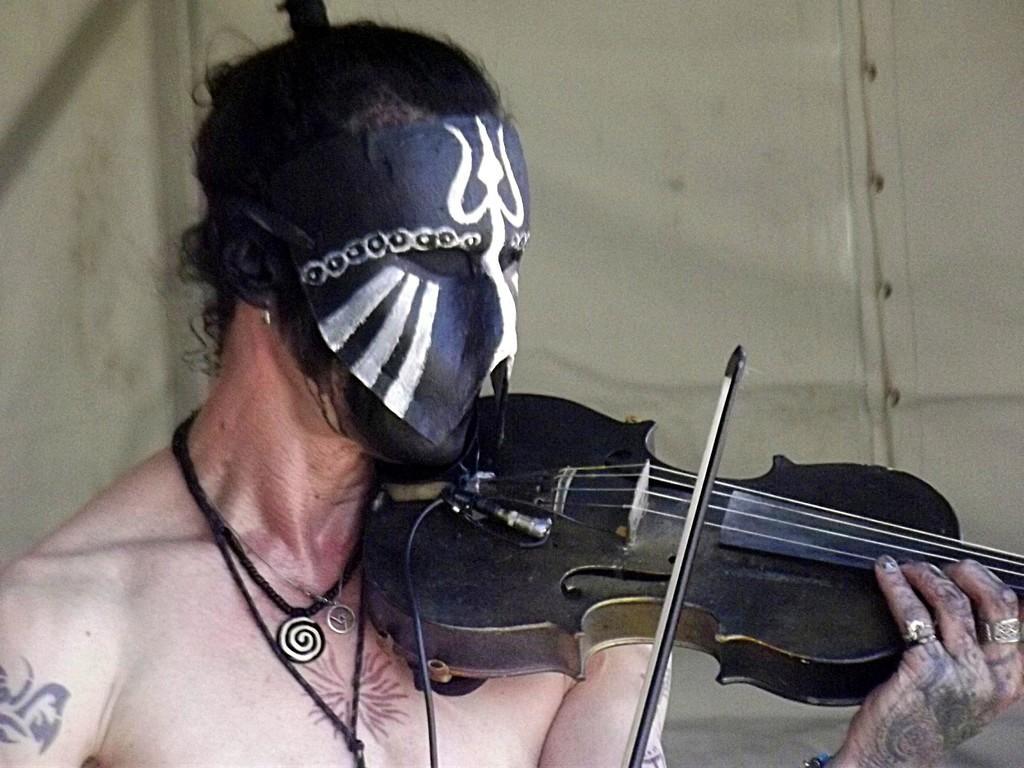Could you give a brief overview of what you see in this image? In this image I can see a person wearing the mask and playing the violin. 